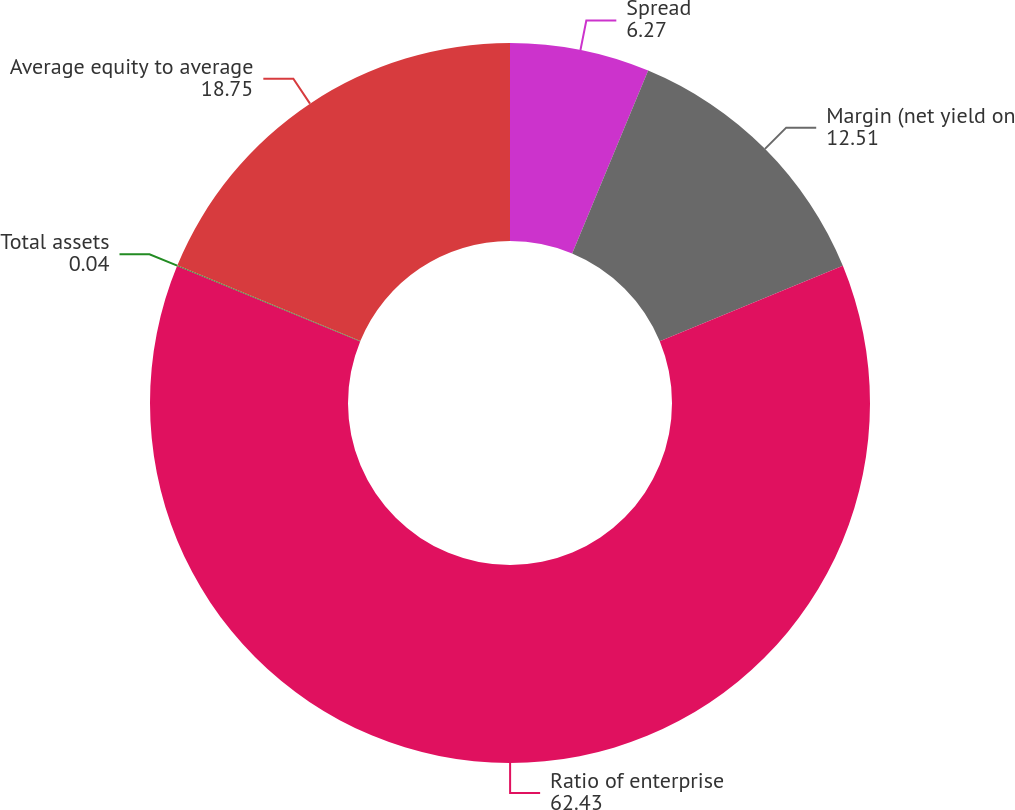<chart> <loc_0><loc_0><loc_500><loc_500><pie_chart><fcel>Spread<fcel>Margin (net yield on<fcel>Ratio of enterprise<fcel>Total assets<fcel>Average equity to average<nl><fcel>6.27%<fcel>12.51%<fcel>62.43%<fcel>0.04%<fcel>18.75%<nl></chart> 